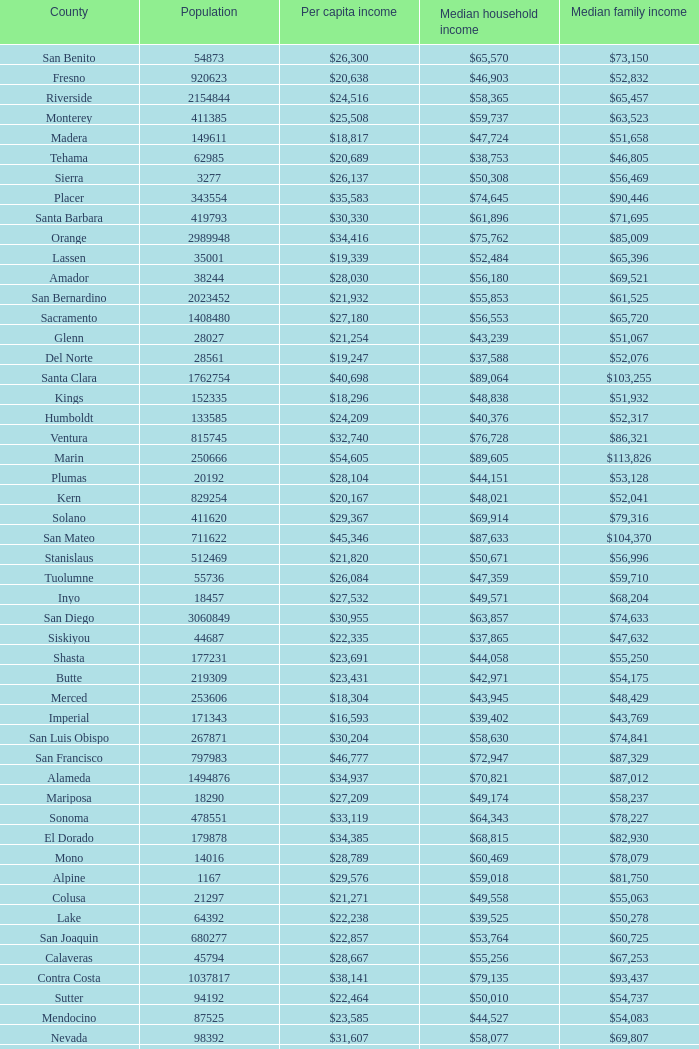What is the median household income of sacramento? $56,553. 